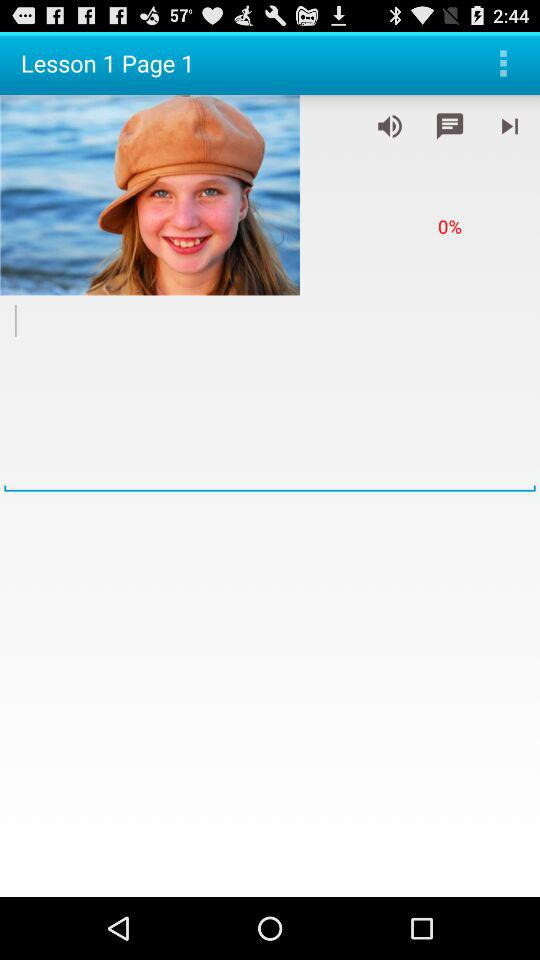Which lesson number is open? The open lesson number is 1. 